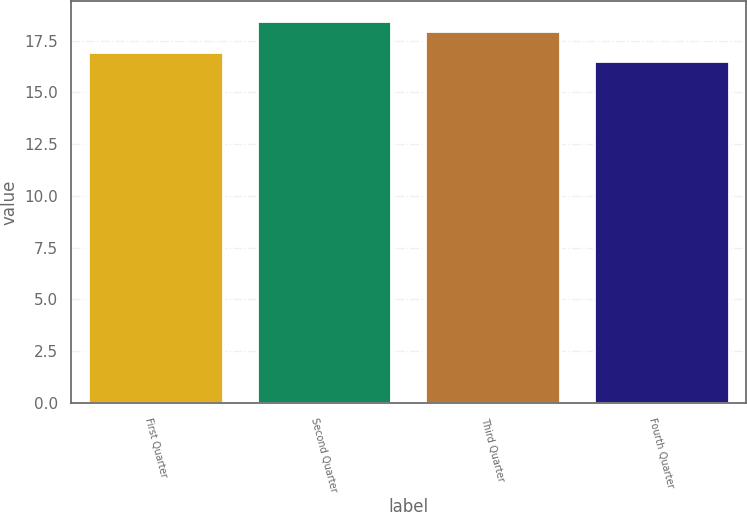<chart> <loc_0><loc_0><loc_500><loc_500><bar_chart><fcel>First Quarter<fcel>Second Quarter<fcel>Third Quarter<fcel>Fourth Quarter<nl><fcel>16.97<fcel>18.47<fcel>17.95<fcel>16.5<nl></chart> 